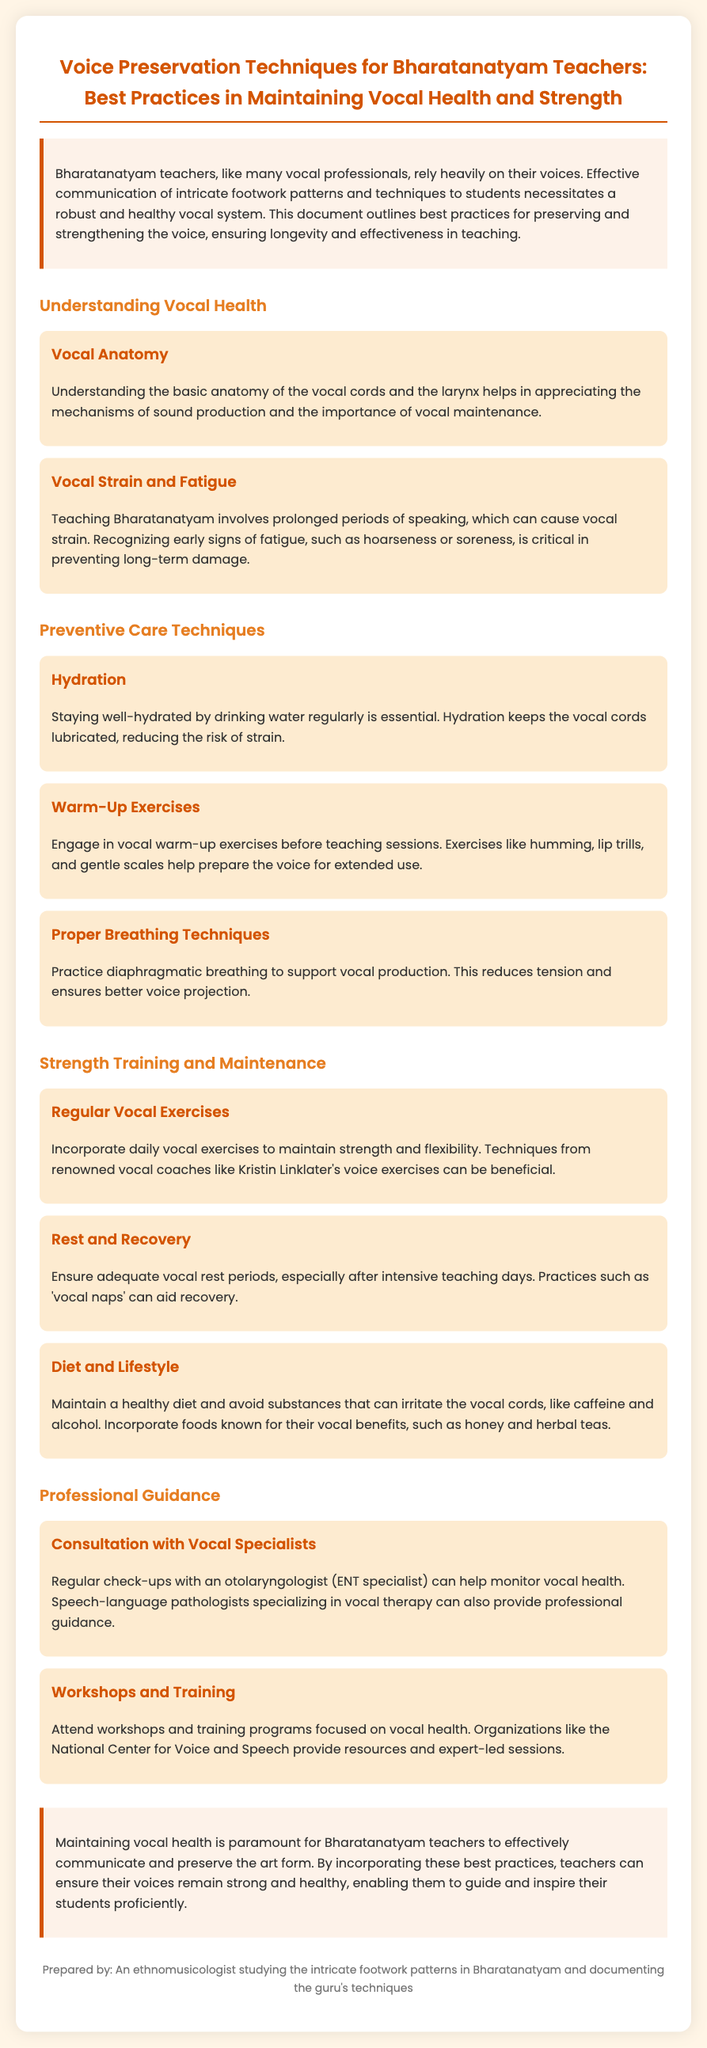What is the title of the document? The title of the document is mentioned at the top and describes the content concerning vocal health for Bharatanatyam teachers.
Answer: Voice Preservation Techniques for Bharatanatyam Teachers: Best Practices in Maintaining Vocal Health and Strength What is the key focus of the introduction? The introduction highlights the reliance of Bharatanatyam teachers on their voices and the importance of vocal health in effective teaching.
Answer: Effective communication of intricate footwork patterns and techniques What are the early signs of vocal fatigue mentioned? The document outlines specific symptoms to recognize early signs of vocal fatigue.
Answer: Hoarseness or soreness What is one recommended technique for vocal strength training? The document suggests specific exercises to maintain vocal strength, highlighting the importance of daily practice.
Answer: Regular Vocal Exercises What is suggested as a dietary consideration for vocal health? The document emphasizes maintaining a healthy diet while avoiding certain irritants for the vocal cords.
Answer: Avoid substances that can irritate the vocal cords Who should Bharatanatyam teachers consult for vocal health monitoring? The document advises regular consultations for professional insights into vocal health.
Answer: An otolaryngologist (ENT specialist) What type of breathing technique is recommended? The document describes a technique essential for better vocal production and support.
Answer: Diaphragmatic breathing What is a suggested practice after intensive teaching days? The document provides a recommendation for recovery to maintain vocal health after demanding teaching sessions.
Answer: Vocal naps 